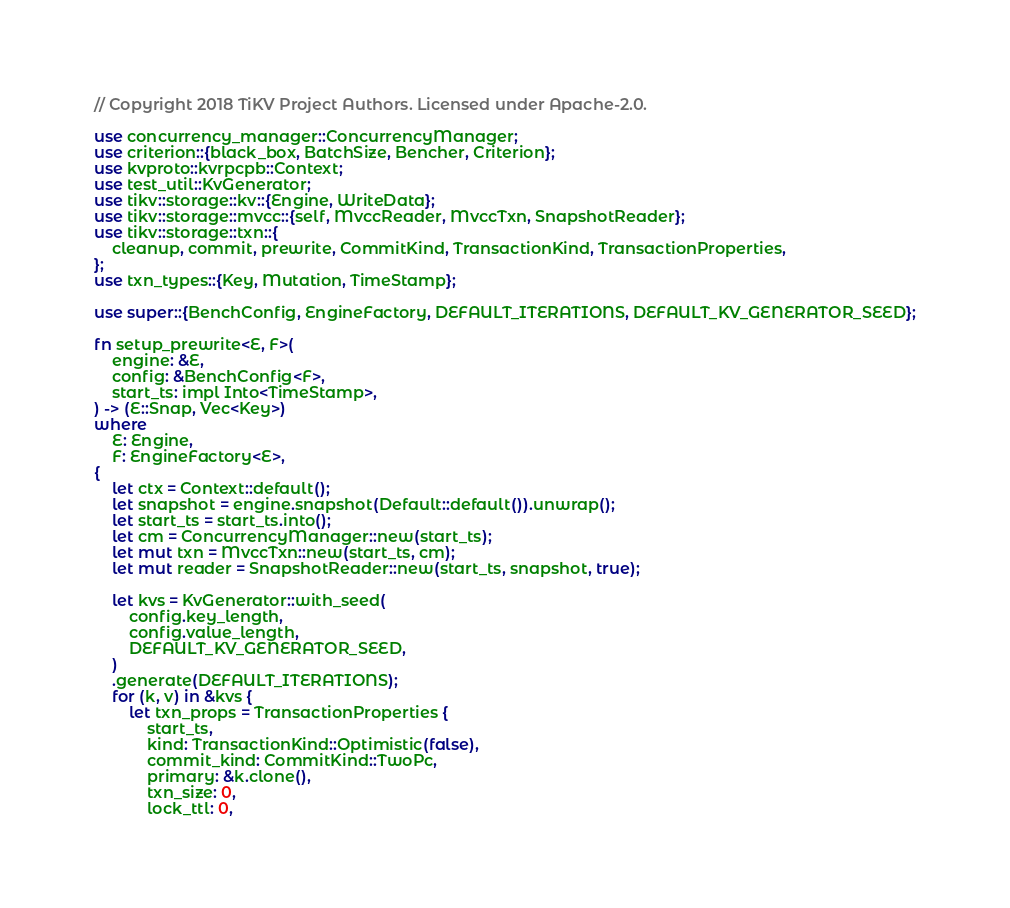Convert code to text. <code><loc_0><loc_0><loc_500><loc_500><_Rust_>// Copyright 2018 TiKV Project Authors. Licensed under Apache-2.0.

use concurrency_manager::ConcurrencyManager;
use criterion::{black_box, BatchSize, Bencher, Criterion};
use kvproto::kvrpcpb::Context;
use test_util::KvGenerator;
use tikv::storage::kv::{Engine, WriteData};
use tikv::storage::mvcc::{self, MvccReader, MvccTxn, SnapshotReader};
use tikv::storage::txn::{
    cleanup, commit, prewrite, CommitKind, TransactionKind, TransactionProperties,
};
use txn_types::{Key, Mutation, TimeStamp};

use super::{BenchConfig, EngineFactory, DEFAULT_ITERATIONS, DEFAULT_KV_GENERATOR_SEED};

fn setup_prewrite<E, F>(
    engine: &E,
    config: &BenchConfig<F>,
    start_ts: impl Into<TimeStamp>,
) -> (E::Snap, Vec<Key>)
where
    E: Engine,
    F: EngineFactory<E>,
{
    let ctx = Context::default();
    let snapshot = engine.snapshot(Default::default()).unwrap();
    let start_ts = start_ts.into();
    let cm = ConcurrencyManager::new(start_ts);
    let mut txn = MvccTxn::new(start_ts, cm);
    let mut reader = SnapshotReader::new(start_ts, snapshot, true);

    let kvs = KvGenerator::with_seed(
        config.key_length,
        config.value_length,
        DEFAULT_KV_GENERATOR_SEED,
    )
    .generate(DEFAULT_ITERATIONS);
    for (k, v) in &kvs {
        let txn_props = TransactionProperties {
            start_ts,
            kind: TransactionKind::Optimistic(false),
            commit_kind: CommitKind::TwoPc,
            primary: &k.clone(),
            txn_size: 0,
            lock_ttl: 0,</code> 